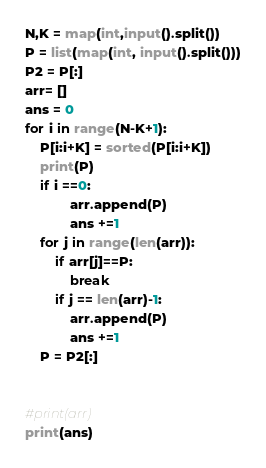<code> <loc_0><loc_0><loc_500><loc_500><_Python_>N,K = map(int,input().split())
P = list(map(int, input().split()))
P2 = P[:]
arr= []
ans = 0
for i in range(N-K+1):
    P[i:i+K] = sorted(P[i:i+K])
    print(P)
    if i ==0:
            arr.append(P)
            ans +=1
    for j in range(len(arr)):
        if arr[j]==P:
            break
        if j == len(arr)-1:
            arr.append(P)
            ans +=1
    P = P2[:]


#print(arr)
print(ans)
</code> 